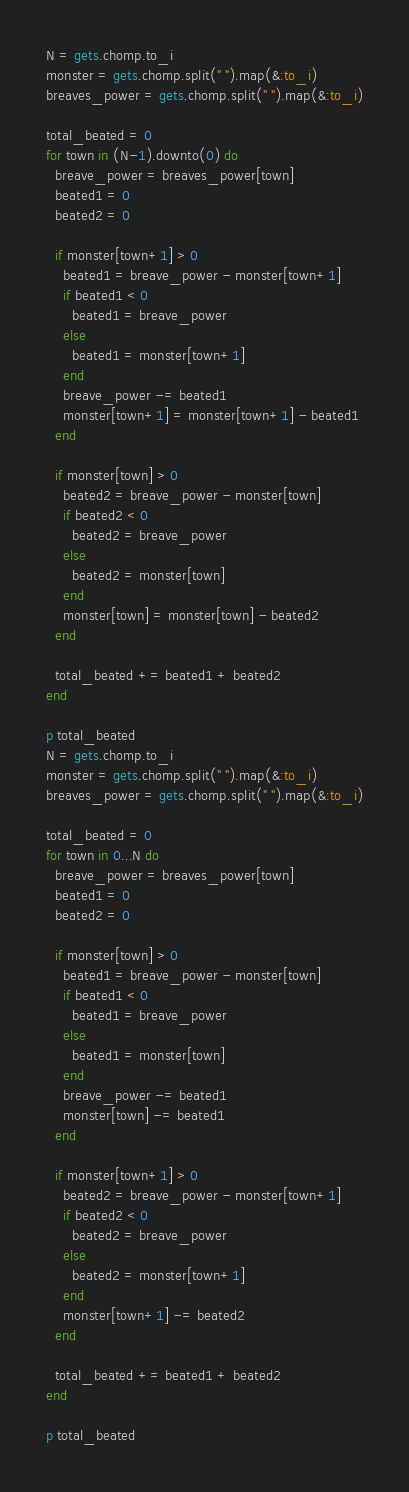Convert code to text. <code><loc_0><loc_0><loc_500><loc_500><_Ruby_>N = gets.chomp.to_i
monster = gets.chomp.split(" ").map(&:to_i)
breaves_power = gets.chomp.split(" ").map(&:to_i)
 
total_beated = 0
for town in (N-1).downto(0) do
  breave_power = breaves_power[town]
  beated1 = 0
  beated2 = 0
 
  if monster[town+1] > 0
    beated1 = breave_power - monster[town+1]
    if beated1 < 0
      beated1 = breave_power
    else
      beated1 = monster[town+1]
    end
    breave_power -= beated1
    monster[town+1] = monster[town+1] - beated1
  end
 
  if monster[town] > 0
    beated2 = breave_power - monster[town]
    if beated2 < 0
      beated2 = breave_power
    else
      beated2 = monster[town]
    end
    monster[town] = monster[town] - beated2
  end
 
  total_beated += beated1 + beated2
end
 
p total_beated
N = gets.chomp.to_i
monster = gets.chomp.split(" ").map(&:to_i)
breaves_power = gets.chomp.split(" ").map(&:to_i)

total_beated = 0
for town in 0...N do
  breave_power = breaves_power[town]
  beated1 = 0
  beated2 = 0

  if monster[town] > 0
    beated1 = breave_power - monster[town]
    if beated1 < 0
      beated1 = breave_power
    else
      beated1 = monster[town]
    end
    breave_power -= beated1
    monster[town] -= beated1
  end

  if monster[town+1] > 0
    beated2 = breave_power - monster[town+1]
    if beated2 < 0
      beated2 = breave_power
    else
      beated2 = monster[town+1]
    end
    monster[town+1] -= beated2
  end

  total_beated += beated1 + beated2
end

p total_beated
</code> 